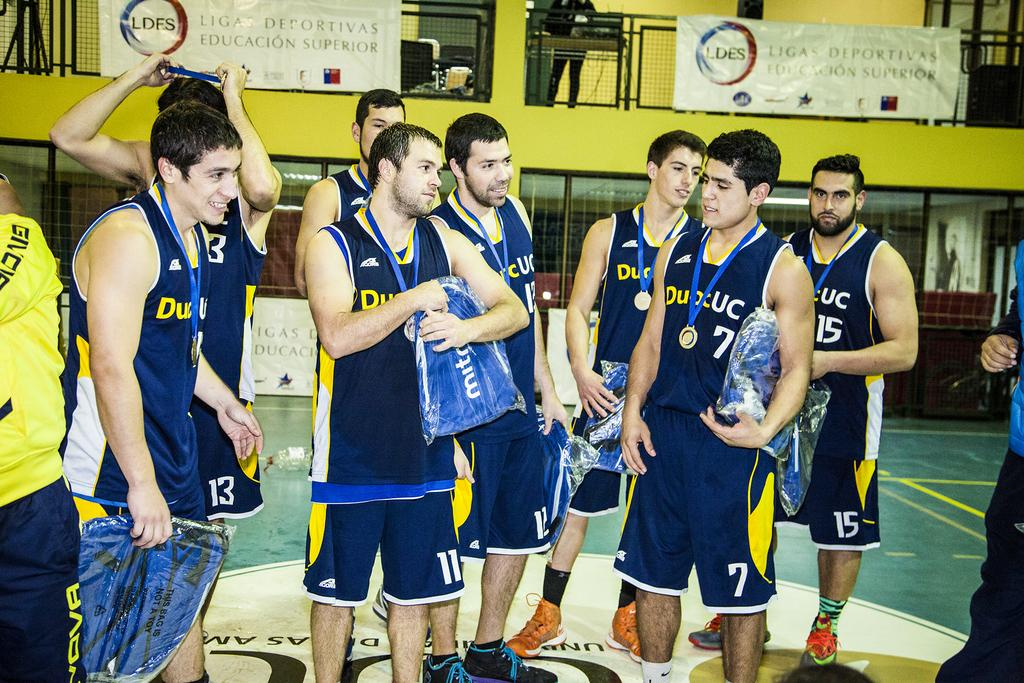How many people are present in the image? There are many people in the image. What are some people wearing in the image? Some people are wearing medals in the image. What are some people holding in their hands in the image? Some people are holding something in their hands in the image. What can be seen in the background of the image? There are banners in the background of the image. What architectural feature is present in the image? There are railings in the image. What type of skin can be seen on the orange in the image? There is no orange present in the image, so there is no skin to observe. What is the can used for in the image? There is no can present in the image, so it cannot be used for anything in the image. 